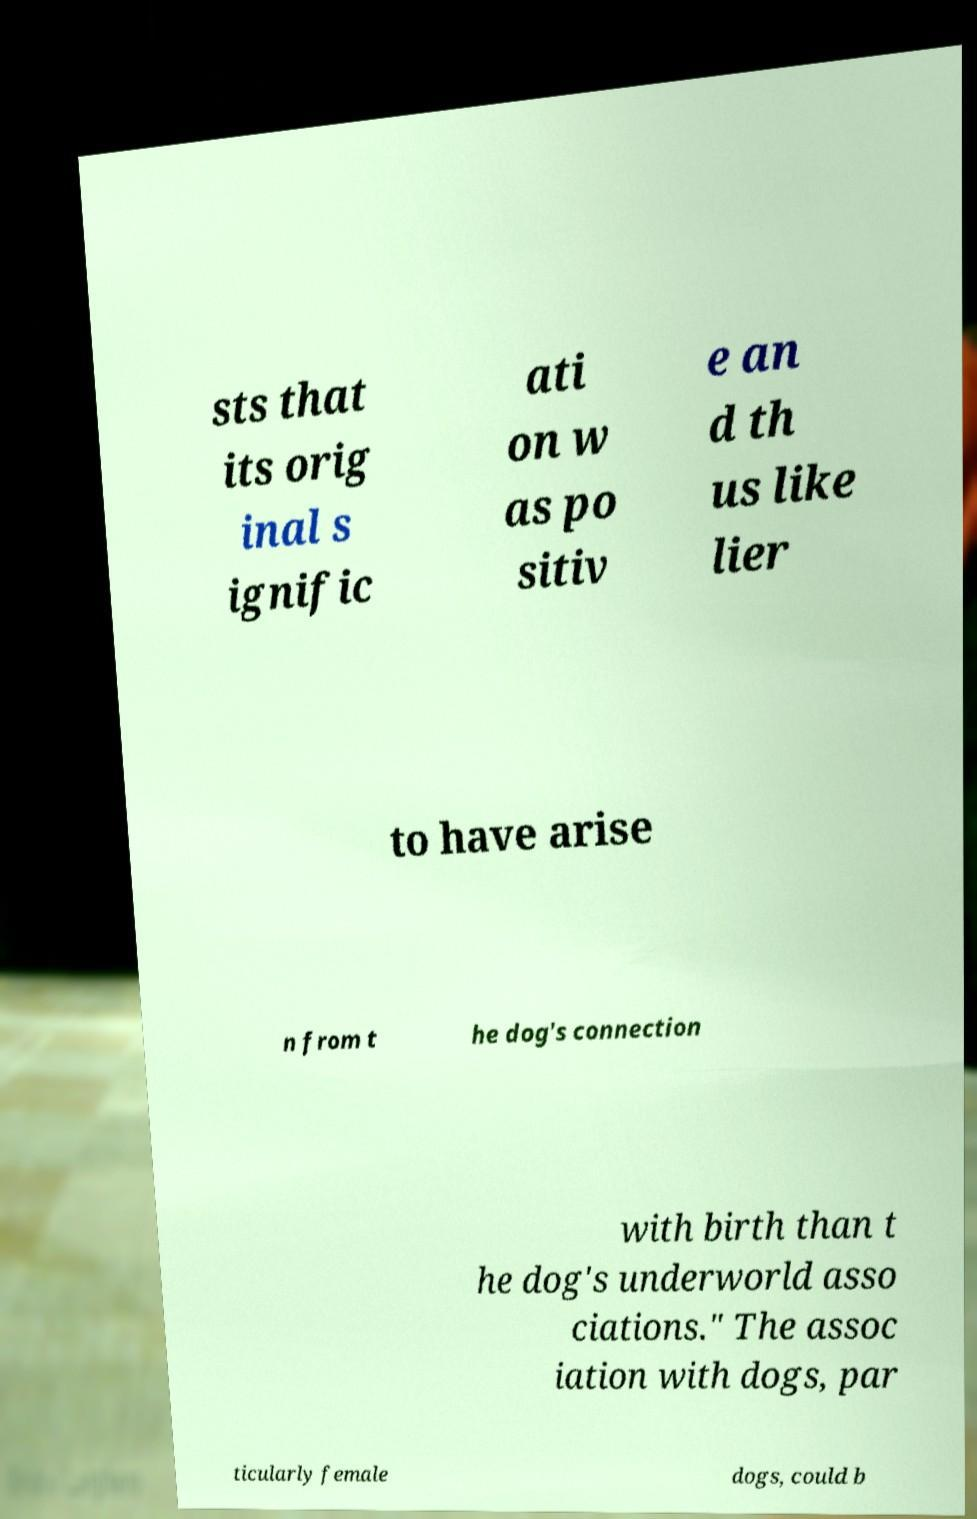Can you accurately transcribe the text from the provided image for me? sts that its orig inal s ignific ati on w as po sitiv e an d th us like lier to have arise n from t he dog's connection with birth than t he dog's underworld asso ciations." The assoc iation with dogs, par ticularly female dogs, could b 